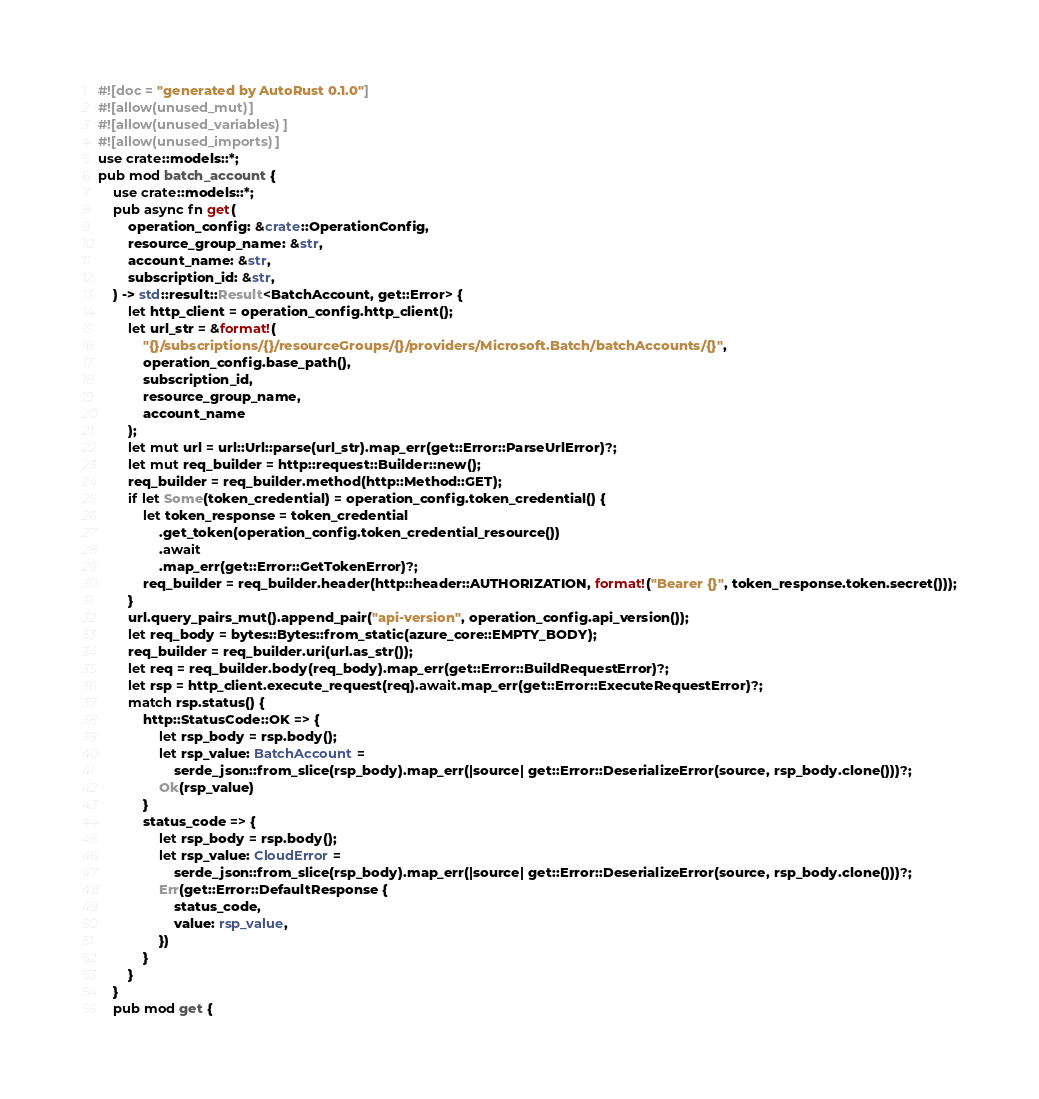Convert code to text. <code><loc_0><loc_0><loc_500><loc_500><_Rust_>#![doc = "generated by AutoRust 0.1.0"]
#![allow(unused_mut)]
#![allow(unused_variables)]
#![allow(unused_imports)]
use crate::models::*;
pub mod batch_account {
    use crate::models::*;
    pub async fn get(
        operation_config: &crate::OperationConfig,
        resource_group_name: &str,
        account_name: &str,
        subscription_id: &str,
    ) -> std::result::Result<BatchAccount, get::Error> {
        let http_client = operation_config.http_client();
        let url_str = &format!(
            "{}/subscriptions/{}/resourceGroups/{}/providers/Microsoft.Batch/batchAccounts/{}",
            operation_config.base_path(),
            subscription_id,
            resource_group_name,
            account_name
        );
        let mut url = url::Url::parse(url_str).map_err(get::Error::ParseUrlError)?;
        let mut req_builder = http::request::Builder::new();
        req_builder = req_builder.method(http::Method::GET);
        if let Some(token_credential) = operation_config.token_credential() {
            let token_response = token_credential
                .get_token(operation_config.token_credential_resource())
                .await
                .map_err(get::Error::GetTokenError)?;
            req_builder = req_builder.header(http::header::AUTHORIZATION, format!("Bearer {}", token_response.token.secret()));
        }
        url.query_pairs_mut().append_pair("api-version", operation_config.api_version());
        let req_body = bytes::Bytes::from_static(azure_core::EMPTY_BODY);
        req_builder = req_builder.uri(url.as_str());
        let req = req_builder.body(req_body).map_err(get::Error::BuildRequestError)?;
        let rsp = http_client.execute_request(req).await.map_err(get::Error::ExecuteRequestError)?;
        match rsp.status() {
            http::StatusCode::OK => {
                let rsp_body = rsp.body();
                let rsp_value: BatchAccount =
                    serde_json::from_slice(rsp_body).map_err(|source| get::Error::DeserializeError(source, rsp_body.clone()))?;
                Ok(rsp_value)
            }
            status_code => {
                let rsp_body = rsp.body();
                let rsp_value: CloudError =
                    serde_json::from_slice(rsp_body).map_err(|source| get::Error::DeserializeError(source, rsp_body.clone()))?;
                Err(get::Error::DefaultResponse {
                    status_code,
                    value: rsp_value,
                })
            }
        }
    }
    pub mod get {</code> 